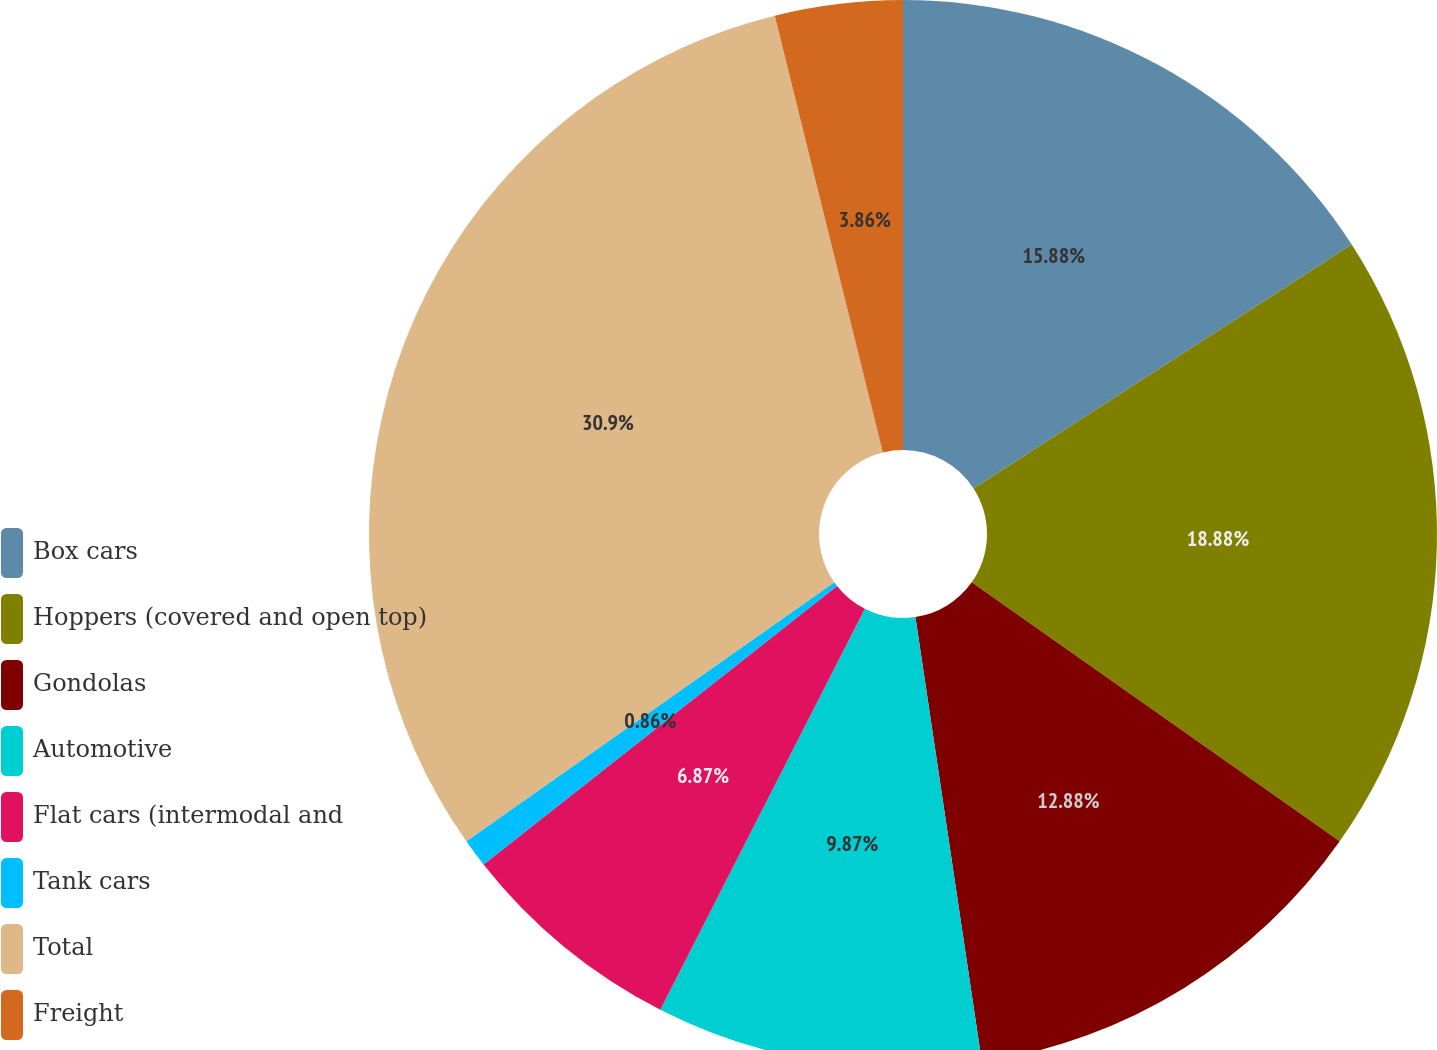Convert chart to OTSL. <chart><loc_0><loc_0><loc_500><loc_500><pie_chart><fcel>Box cars<fcel>Hoppers (covered and open top)<fcel>Gondolas<fcel>Automotive<fcel>Flat cars (intermodal and<fcel>Tank cars<fcel>Total<fcel>Freight<nl><fcel>15.88%<fcel>18.88%<fcel>12.88%<fcel>9.87%<fcel>6.87%<fcel>0.86%<fcel>30.9%<fcel>3.86%<nl></chart> 